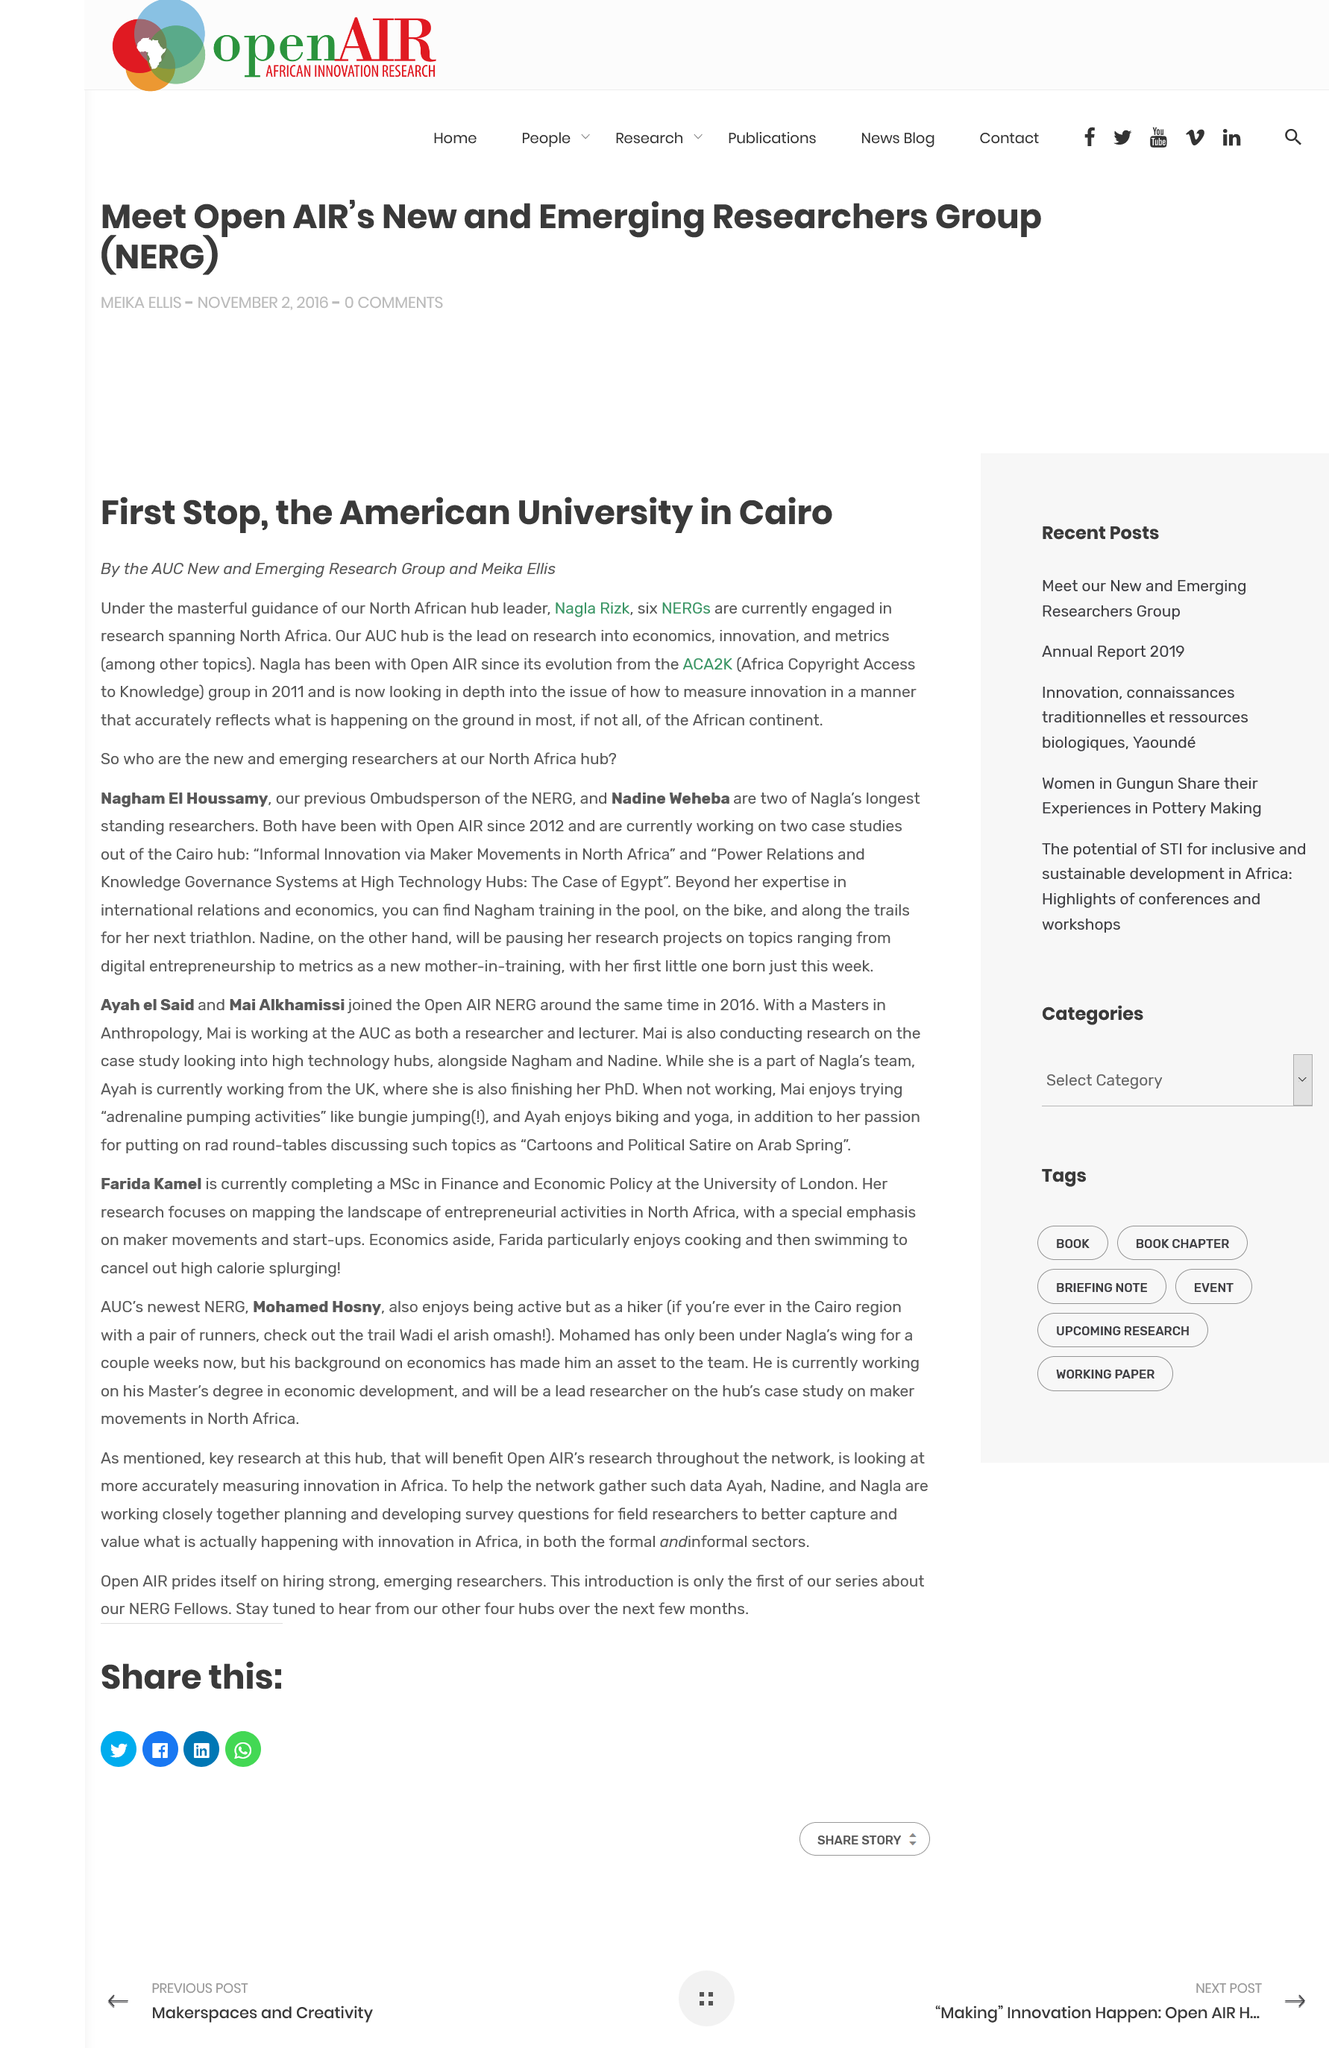Highlight a few significant elements in this photo. The acronym "ACA2K" stands for "Africa Copyright Access to Knowledge," which is a declaration of the organization's commitment to promoting knowledge access in Africa through copyright laws and regulations. Nagla Rizk is the North African hub leader. The American University is located in Cairo, as it is stated in the text. 